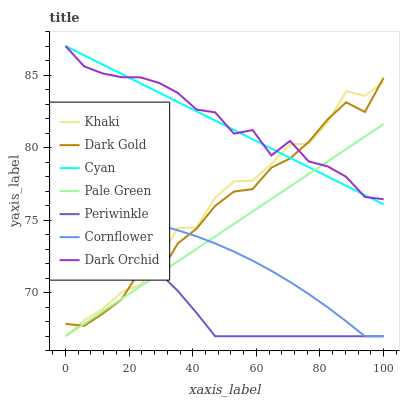Does Periwinkle have the minimum area under the curve?
Answer yes or no. Yes. Does Dark Orchid have the maximum area under the curve?
Answer yes or no. Yes. Does Khaki have the minimum area under the curve?
Answer yes or no. No. Does Khaki have the maximum area under the curve?
Answer yes or no. No. Is Cyan the smoothest?
Answer yes or no. Yes. Is Dark Gold the roughest?
Answer yes or no. Yes. Is Khaki the smoothest?
Answer yes or no. No. Is Khaki the roughest?
Answer yes or no. No. Does Cornflower have the lowest value?
Answer yes or no. Yes. Does Dark Gold have the lowest value?
Answer yes or no. No. Does Cyan have the highest value?
Answer yes or no. Yes. Does Khaki have the highest value?
Answer yes or no. No. Is Periwinkle less than Dark Orchid?
Answer yes or no. Yes. Is Dark Orchid greater than Cornflower?
Answer yes or no. Yes. Does Pale Green intersect Dark Gold?
Answer yes or no. Yes. Is Pale Green less than Dark Gold?
Answer yes or no. No. Is Pale Green greater than Dark Gold?
Answer yes or no. No. Does Periwinkle intersect Dark Orchid?
Answer yes or no. No. 